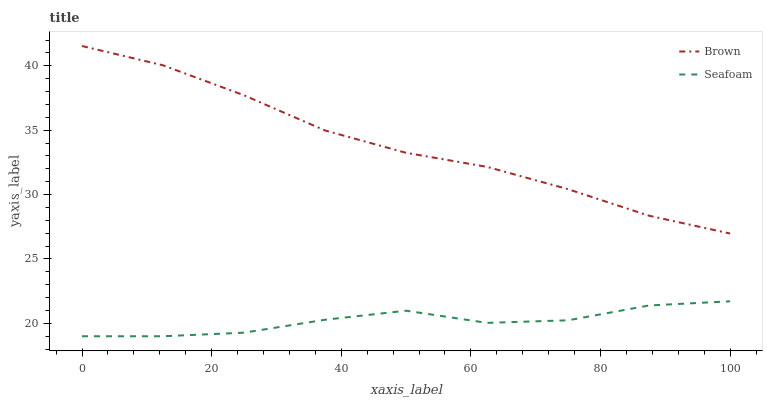Does Seafoam have the minimum area under the curve?
Answer yes or no. Yes. Does Brown have the maximum area under the curve?
Answer yes or no. Yes. Does Seafoam have the maximum area under the curve?
Answer yes or no. No. Is Brown the smoothest?
Answer yes or no. Yes. Is Seafoam the roughest?
Answer yes or no. Yes. Is Seafoam the smoothest?
Answer yes or no. No. Does Seafoam have the lowest value?
Answer yes or no. Yes. Does Brown have the highest value?
Answer yes or no. Yes. Does Seafoam have the highest value?
Answer yes or no. No. Is Seafoam less than Brown?
Answer yes or no. Yes. Is Brown greater than Seafoam?
Answer yes or no. Yes. Does Seafoam intersect Brown?
Answer yes or no. No. 